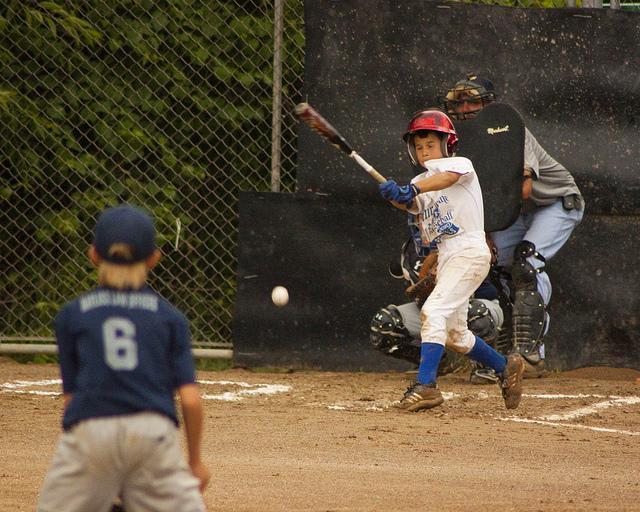How many people can you see?
Give a very brief answer. 5. 